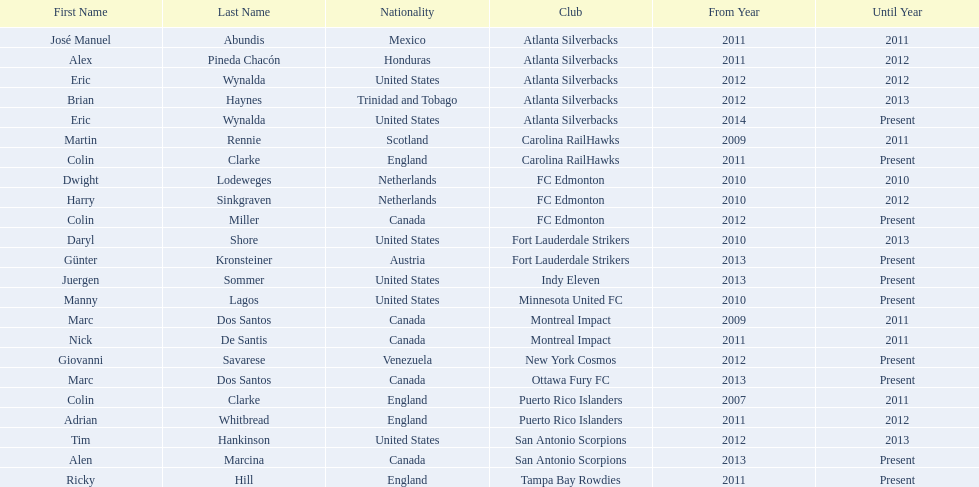Who was the coach of fc edmonton before miller? Harry Sinkgraven. 